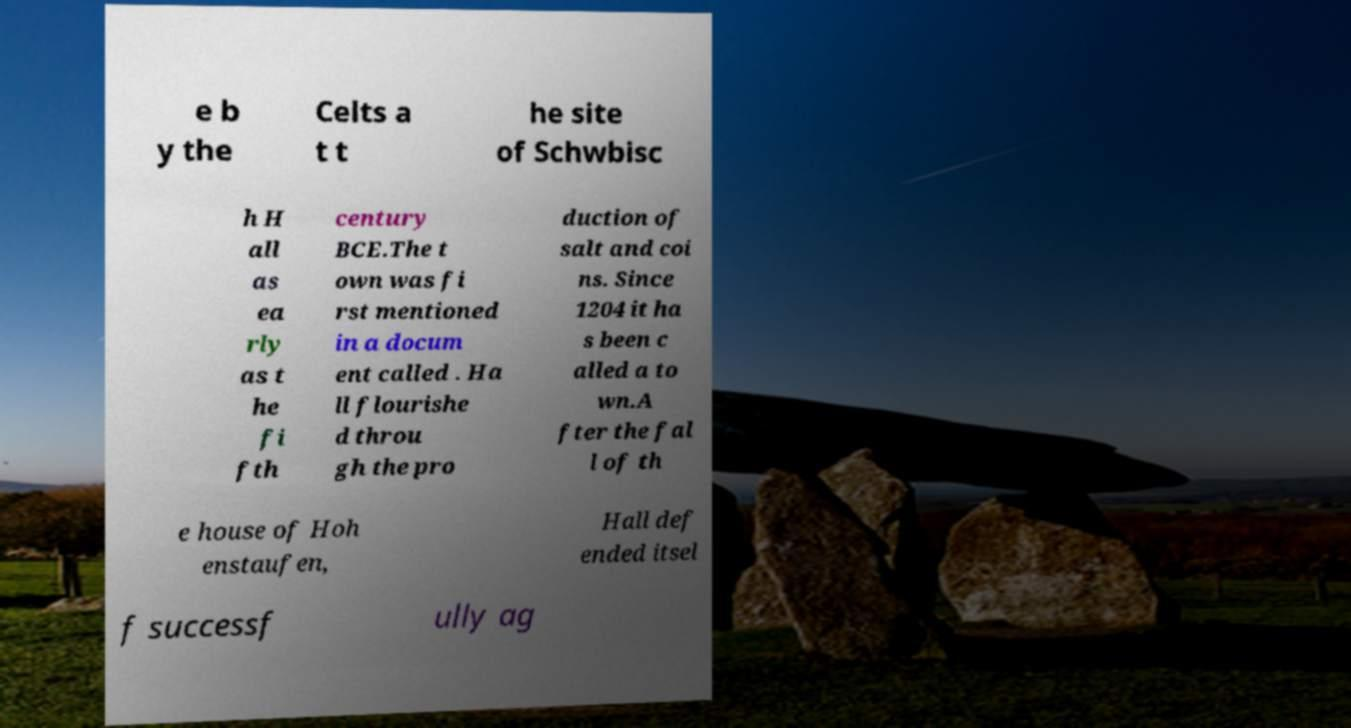There's text embedded in this image that I need extracted. Can you transcribe it verbatim? e b y the Celts a t t he site of Schwbisc h H all as ea rly as t he fi fth century BCE.The t own was fi rst mentioned in a docum ent called . Ha ll flourishe d throu gh the pro duction of salt and coi ns. Since 1204 it ha s been c alled a to wn.A fter the fal l of th e house of Hoh enstaufen, Hall def ended itsel f successf ully ag 